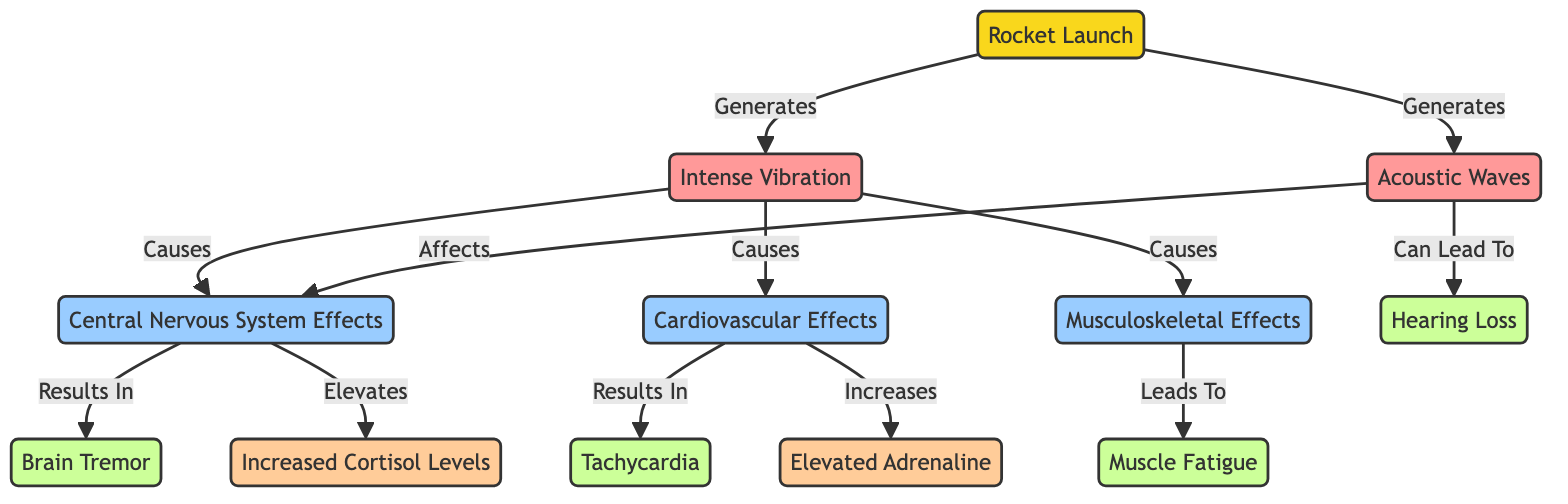What are the main physical phenomena generated by a rocket launch? The diagram indicates that a rocket launch generates two main physical phenomena: intense vibration and acoustic waves. These are explicitly marked as outcomes of the rocket launch node.
Answer: Intense Vibration and Acoustic Waves Which physiological effect is associated with increased cortisol levels? According to the diagram, increased cortisol levels are a result of central nervous system effects, which is indicated by the arrow connecting these two nodes.
Answer: Central Nervous System Effects How many types of physiological effects are specified in the diagram? The diagram shows three types of physiological effects: central nervous system effects, cardiovascular effects, and musculoskeletal effects. Counting these distinct nodes leads to the answer.
Answer: Three What is the relationship between acoustic waves and hearing loss? The diagram displays a direct connection indicating that acoustic waves can lead to hearing loss, stating that acoustic waves affect central nervous system effects and the consequent results here include hearing loss.
Answer: Can Lead To Which stress marker is increased due to cardiovascular effects? The diagram shows that cardiovascular effects increase adrenaline levels, illustrating the specific relationship between these two entities within the outlined effects.
Answer: Adrenaline What physiological effect results from cardiovascular effects? The flowchart establishes a direct link where cardiovascular effects result in tachycardia, clearly labeling this outcome in the diagram.
Answer: Tachycardia What is the consequence of musculoskeletal effects? According to the flowchart, musculoskeletal effects lead to muscle fatigue, which denotes a direct outcome of the and is highlighted as a result.
Answer: Muscle Fatigue How many total nodes are present in the diagram depicting effects of rocket launches? The diagram includes a total of eight nodes: three types of physiological effects, two stress indicators, and three effects. By counting each labeled node, we find the total.
Answer: Eight 